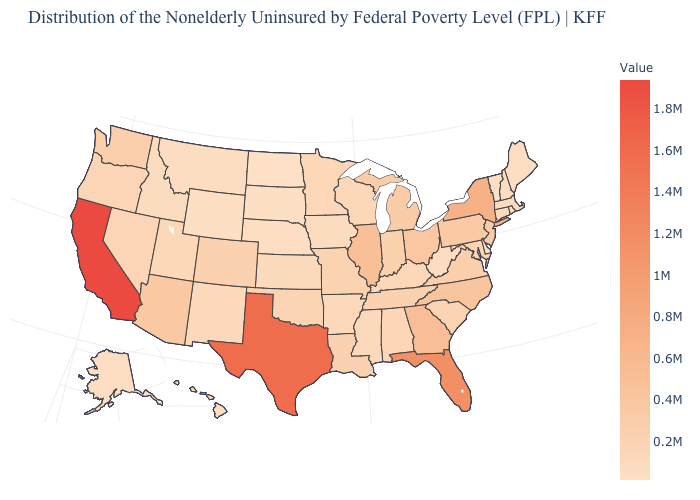Among the states that border South Dakota , does North Dakota have the lowest value?
Concise answer only. Yes. Does the map have missing data?
Quick response, please. No. Is the legend a continuous bar?
Give a very brief answer. Yes. 